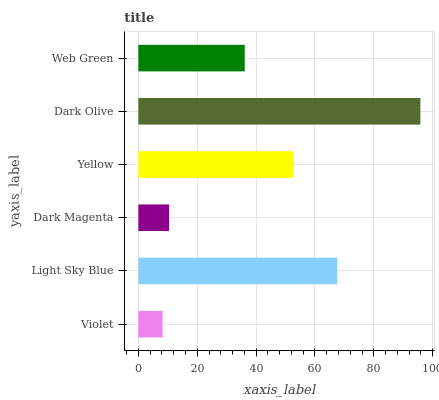Is Violet the minimum?
Answer yes or no. Yes. Is Dark Olive the maximum?
Answer yes or no. Yes. Is Light Sky Blue the minimum?
Answer yes or no. No. Is Light Sky Blue the maximum?
Answer yes or no. No. Is Light Sky Blue greater than Violet?
Answer yes or no. Yes. Is Violet less than Light Sky Blue?
Answer yes or no. Yes. Is Violet greater than Light Sky Blue?
Answer yes or no. No. Is Light Sky Blue less than Violet?
Answer yes or no. No. Is Yellow the high median?
Answer yes or no. Yes. Is Web Green the low median?
Answer yes or no. Yes. Is Dark Olive the high median?
Answer yes or no. No. Is Yellow the low median?
Answer yes or no. No. 